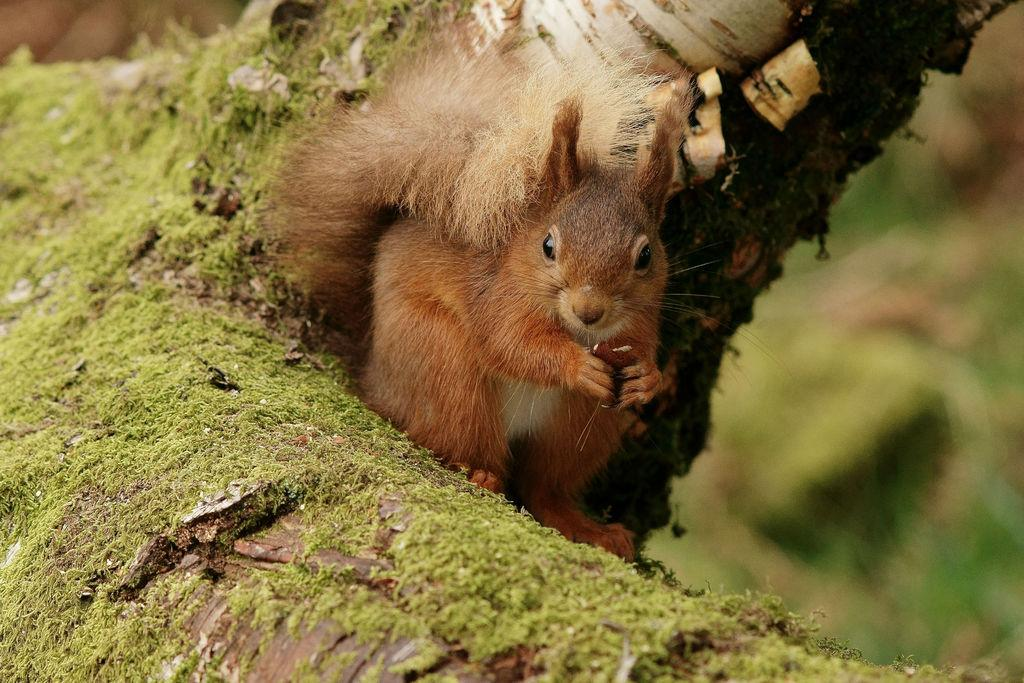What type of animal is in the image? There is a brown squirrel in the image. What is the squirrel doing in the image? The squirrel is holding something. How would you describe the quality of the image's background? The image is blurry in the background. What type of yam is the queen holding in the image? There is no queen or yam present in the image; it features a brown squirrel holding something. On which side of the image is the yam located? There is no yam present in the image, so it cannot be located on any side. 